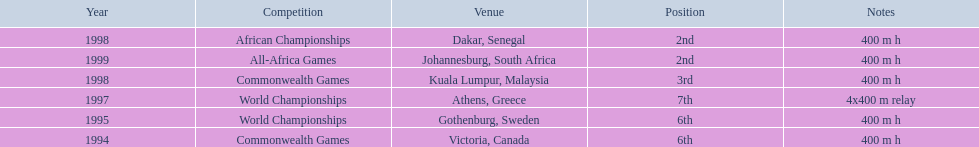What was the venue before dakar, senegal? Kuala Lumpur, Malaysia. 